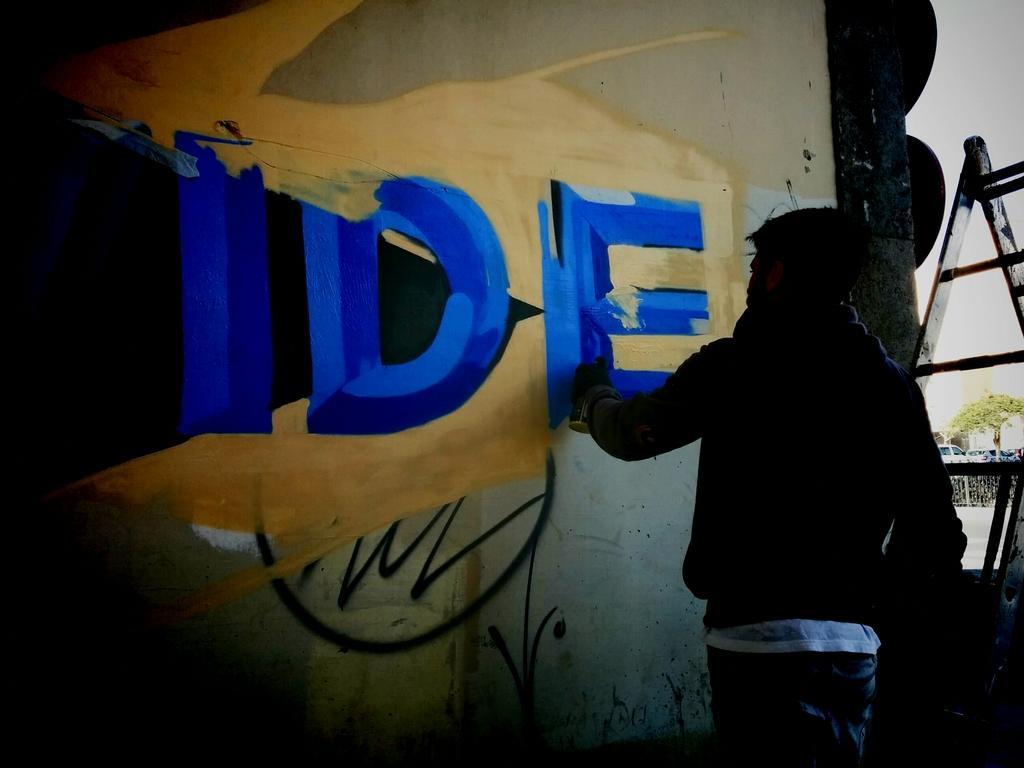Could you give a brief overview of what you see in this image? In this image we can see one man standing near the wall, holding a graffiti bottle and painting graffiti. There is one ladder beside the man, one tree, some vehicles near the tree, some objects on the floor and two objects attached to the wall. 